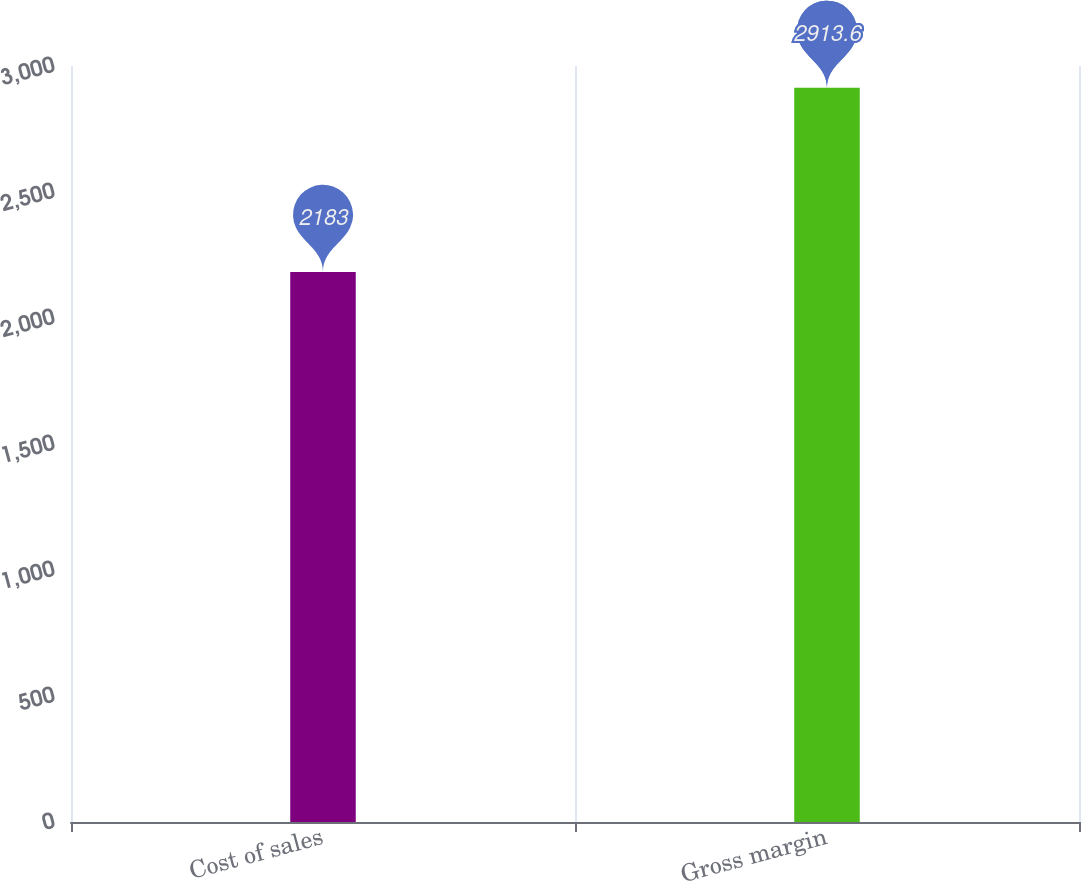<chart> <loc_0><loc_0><loc_500><loc_500><bar_chart><fcel>Cost of sales<fcel>Gross margin<nl><fcel>2183<fcel>2913.6<nl></chart> 